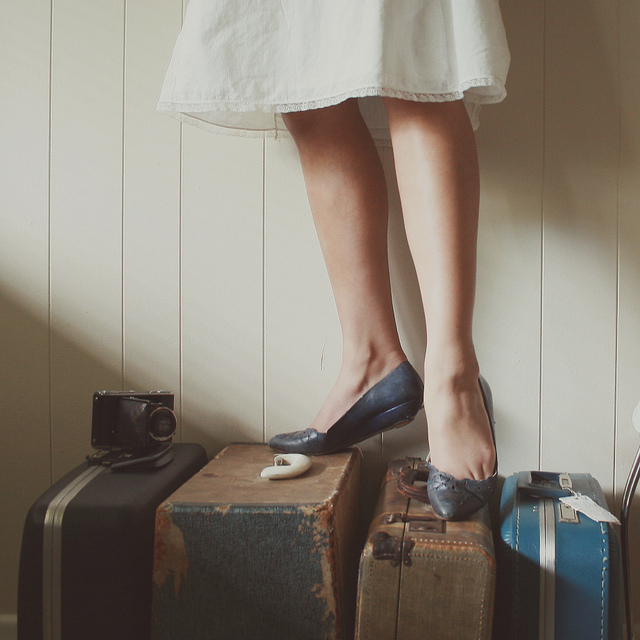How many motorcycles are shown? 0 